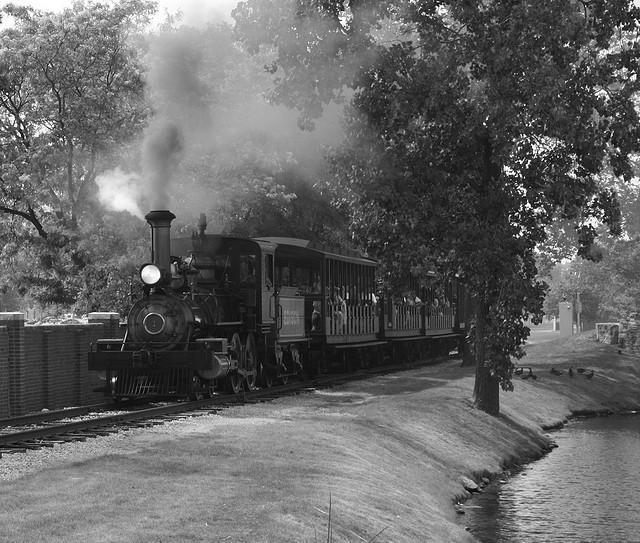How many clear bottles of wine are on the table?
Give a very brief answer. 0. 